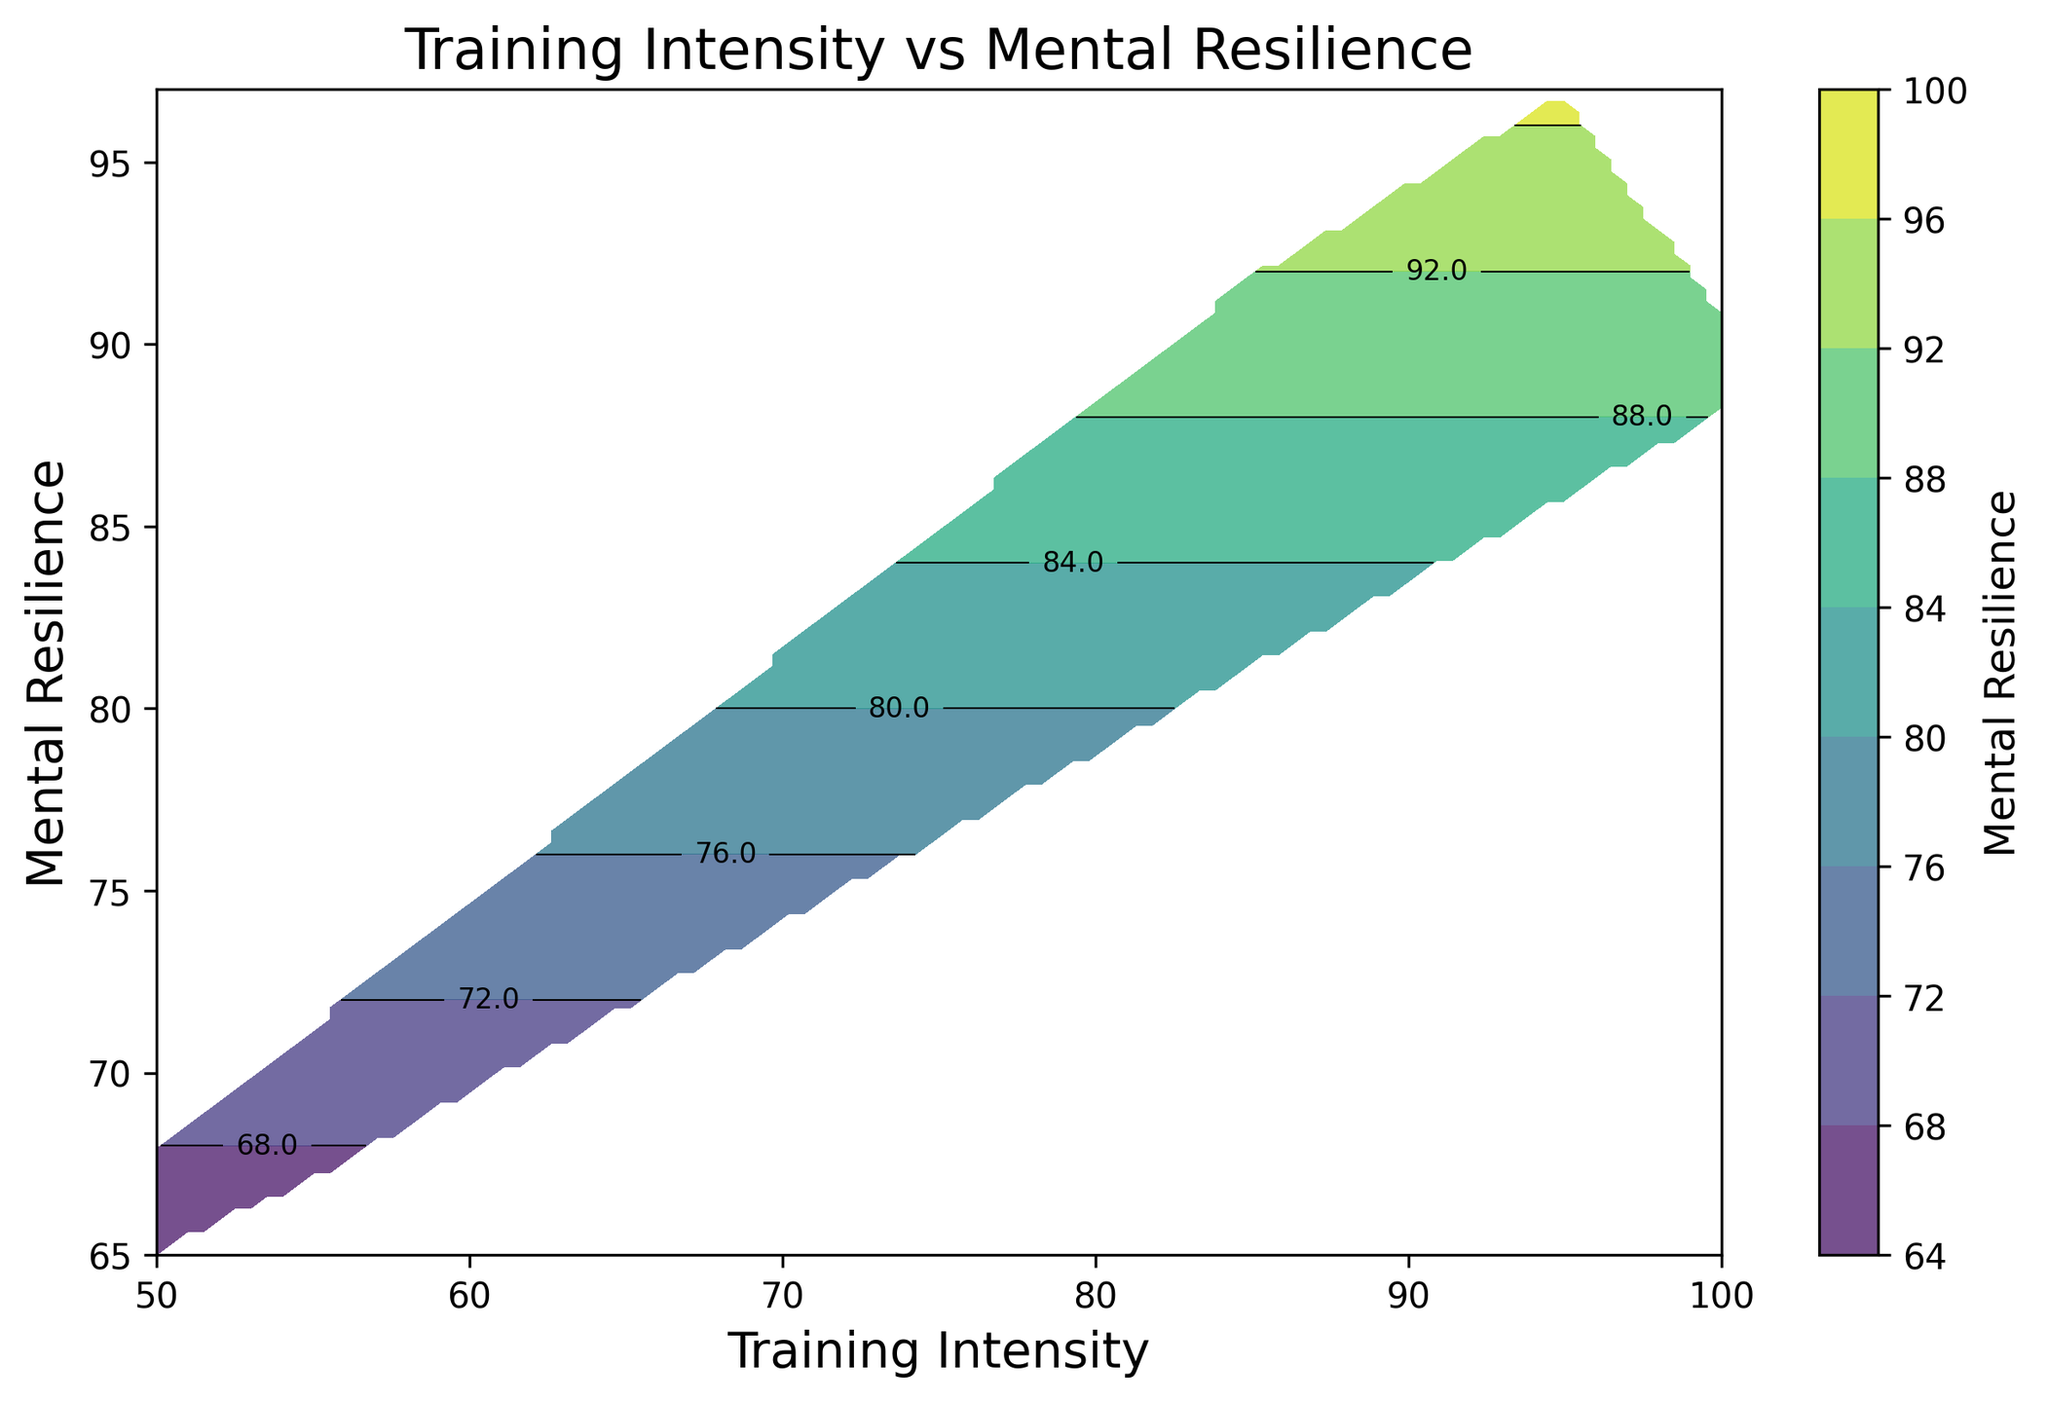What is the training intensity corresponding to the highest level of mental resilience? Observing the contour plot, the highest mental resilience recorded is at around 95-97, and the corresponding training intensity where this peak occurs is around 95.
Answer: 95 How does mental resilience change as training intensity increases from 50 to 100? From the contour plot, mental resilience generally increases as training intensity rises from 50 to a peak around 90-95, then slightly decreases as the intensity approaches 100.
Answer: Increases, then slightly decreases Compare the mental resilience values at training intensities of 60 and 80. Which one is higher? At an intensity of 60, mental resilience is around 70-73, whereas at 80, it is around 86-88. Clearly, mental resilience is higher at an intensity of 80.
Answer: 80 Which training intensity range shows the most significant increase in mental resilience? By observing the plot, the steepest gradient is seen between 70 and 80, where the mental resilience increases significantly.
Answer: 70-80 How does the color change in the contour plot as training intensity increases from 50 to 100? The color changes from lighter shades (indicating lower resilience) at intensity 50 to darker shades (indicating higher resilience) as it approaches 90-95, then lightens slightly as it moves towards 100.
Answer: Light to dark to light What is the mental resilience value when the training intensity is 70? Examining the corresponding contour line at intensity 70, the mental resilience value at this point is around 78-80.
Answer: 78-80 Is there a noticeable drop in mental resilience at any point as training intensity increases? There's a noticeable drop in mental resilience when moving from an intensity of 95 to 100, where resilience falls off from a peak value.
Answer: Yes What intensity range corresponds to the darkest color region in the plot? The darkest color region in the plot, indicating the highest mental resilience, corresponds to the training intensity range of 85 to 95.
Answer: 85-95 What trend can be observed about the overall relationship between training intensity and mental resilience? The overall trend is an increase in mental resilience with increasing training intensity until a point (around 90-95), after which mental resilience slightly declines as intensity further increases to 100.
Answer: Increases then slightly decreases How does mental resilience at an intensity of 50 compare to that at an intensity of 100? At an intensity of 50, mental resilience ranges from 65-68, whereas at 100, it ranges from 88-91. Thus, mental resilience is notably higher at an intensity of 100.
Answer: Higher at 100 